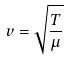Convert formula to latex. <formula><loc_0><loc_0><loc_500><loc_500>v = \sqrt { \frac { T } { \mu } }</formula> 